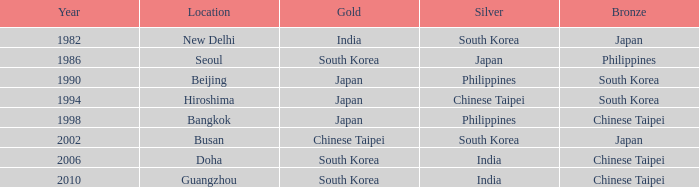In how many years has japan achieved silver? 1986.0. 